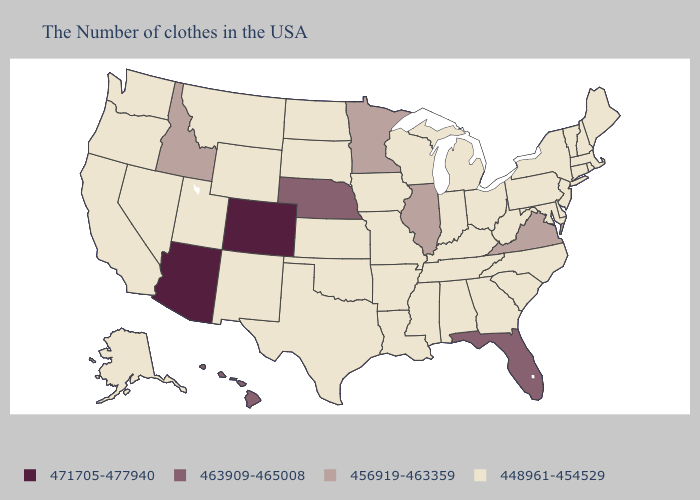Name the states that have a value in the range 463909-465008?
Keep it brief. Florida, Nebraska, Hawaii. Does North Carolina have the highest value in the South?
Concise answer only. No. What is the value of Minnesota?
Answer briefly. 456919-463359. Name the states that have a value in the range 448961-454529?
Write a very short answer. Maine, Massachusetts, Rhode Island, New Hampshire, Vermont, Connecticut, New York, New Jersey, Delaware, Maryland, Pennsylvania, North Carolina, South Carolina, West Virginia, Ohio, Georgia, Michigan, Kentucky, Indiana, Alabama, Tennessee, Wisconsin, Mississippi, Louisiana, Missouri, Arkansas, Iowa, Kansas, Oklahoma, Texas, South Dakota, North Dakota, Wyoming, New Mexico, Utah, Montana, Nevada, California, Washington, Oregon, Alaska. Name the states that have a value in the range 471705-477940?
Write a very short answer. Colorado, Arizona. Which states have the lowest value in the South?
Give a very brief answer. Delaware, Maryland, North Carolina, South Carolina, West Virginia, Georgia, Kentucky, Alabama, Tennessee, Mississippi, Louisiana, Arkansas, Oklahoma, Texas. Does Illinois have the lowest value in the USA?
Concise answer only. No. What is the value of South Dakota?
Short answer required. 448961-454529. Name the states that have a value in the range 471705-477940?
Be succinct. Colorado, Arizona. What is the value of Minnesota?
Short answer required. 456919-463359. Does Pennsylvania have the lowest value in the USA?
Write a very short answer. Yes. Does Vermont have a lower value than Nebraska?
Quick response, please. Yes. Which states have the lowest value in the USA?
Write a very short answer. Maine, Massachusetts, Rhode Island, New Hampshire, Vermont, Connecticut, New York, New Jersey, Delaware, Maryland, Pennsylvania, North Carolina, South Carolina, West Virginia, Ohio, Georgia, Michigan, Kentucky, Indiana, Alabama, Tennessee, Wisconsin, Mississippi, Louisiana, Missouri, Arkansas, Iowa, Kansas, Oklahoma, Texas, South Dakota, North Dakota, Wyoming, New Mexico, Utah, Montana, Nevada, California, Washington, Oregon, Alaska. Does Wisconsin have a lower value than Texas?
Quick response, please. No. Does the map have missing data?
Quick response, please. No. 